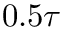Convert formula to latex. <formula><loc_0><loc_0><loc_500><loc_500>0 . 5 \tau</formula> 